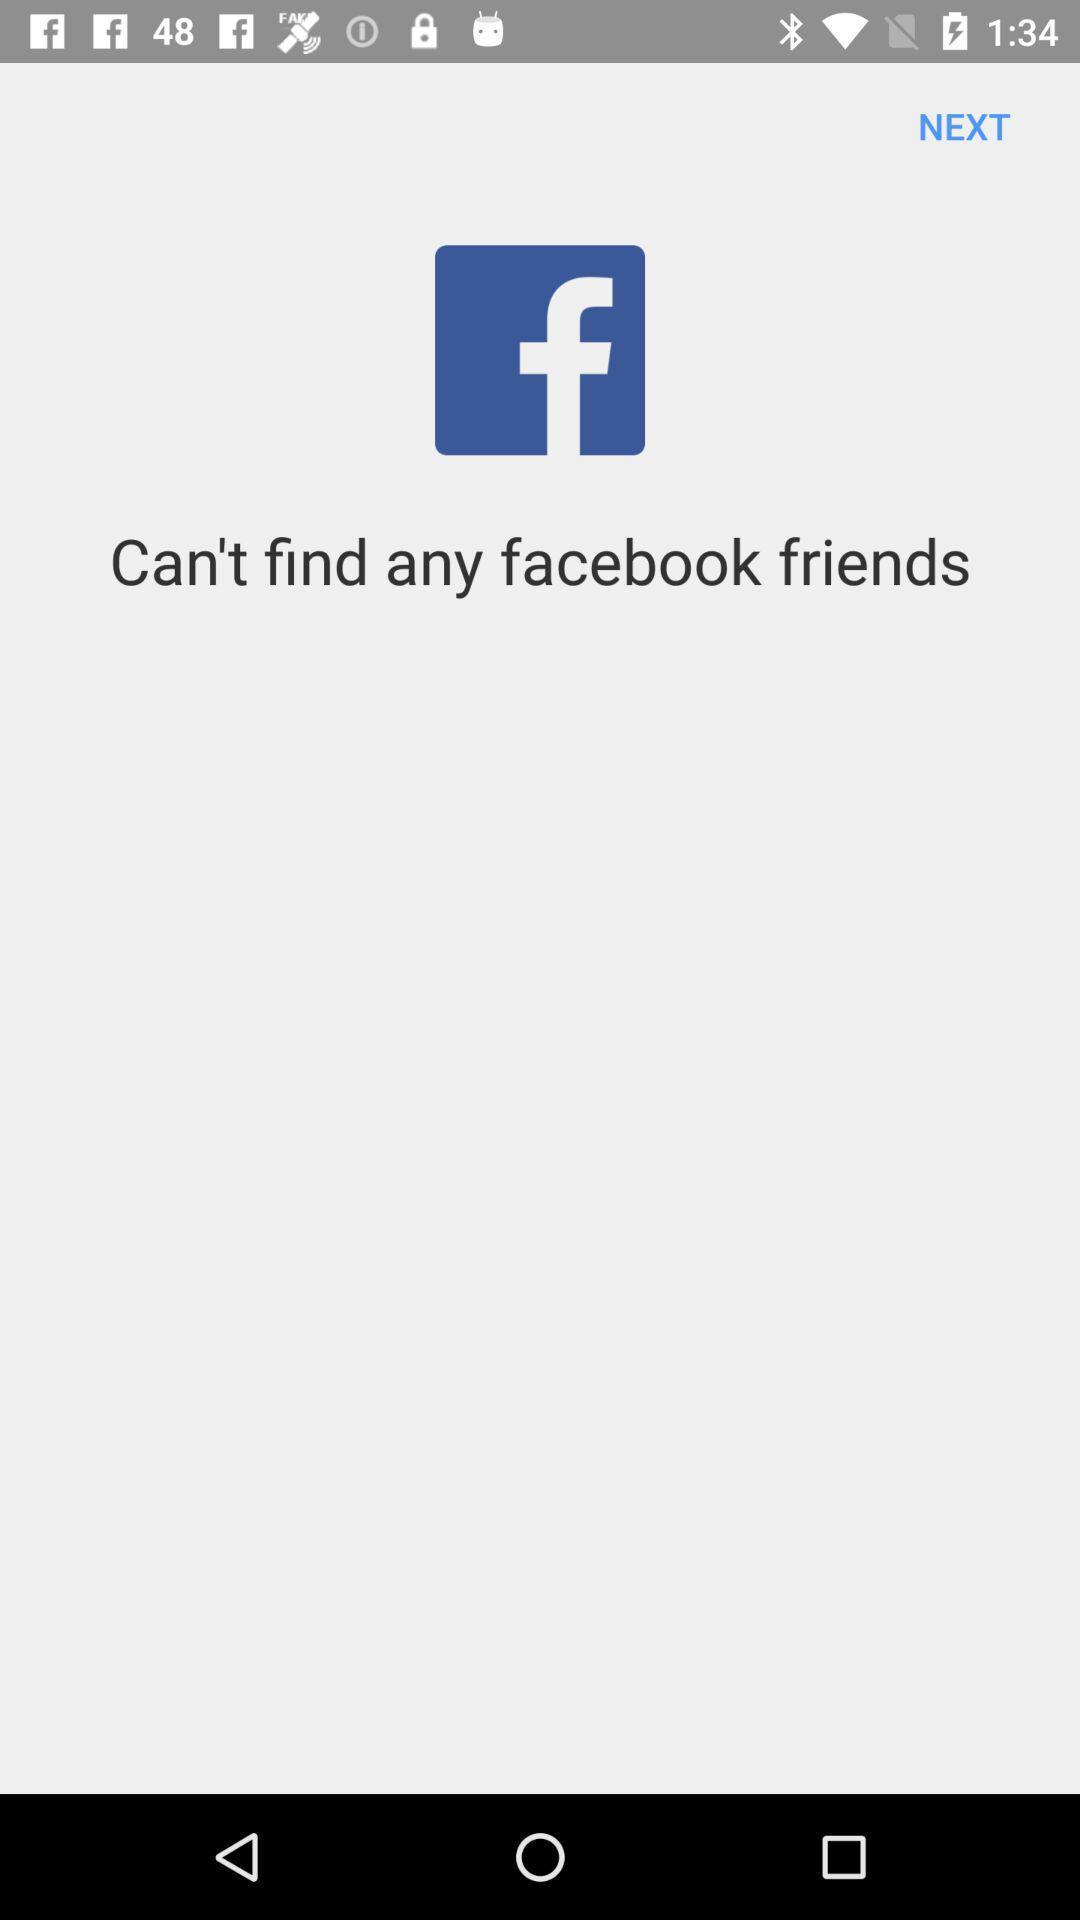Tell me about the visual elements in this screen capture. Window displaying a social app. 